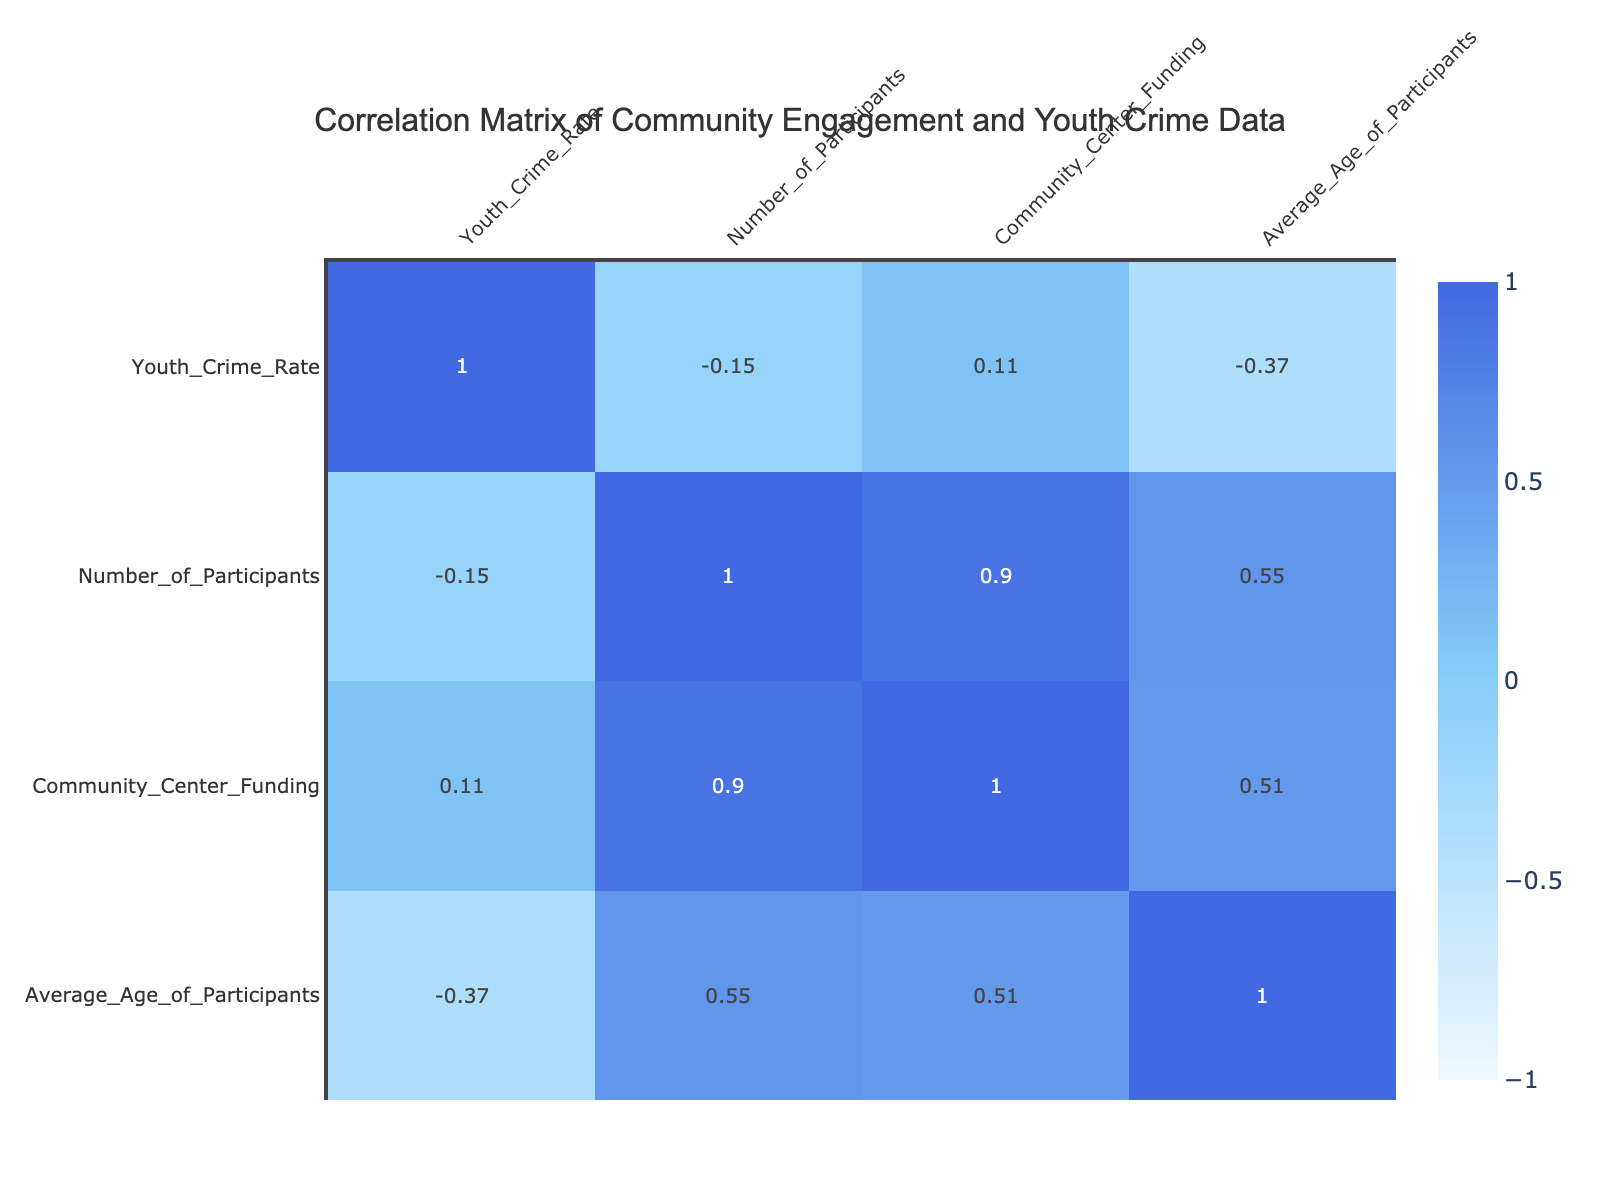What is the youth crime rate associated with Neighborhood Watch Initiatives? Referring to the table, the youth crime rate for Neighborhood Watch Initiatives is specifically listed as 20.
Answer: 20 What community engagement activity has the highest youth crime rate? When examining the table, School-based Presentations has the highest youth crime rate, recorded at 40.
Answer: School-based Presentations What is the average number of participants across all community engagement activities? To calculate the average, sum the number of participants (150 + 100 + 80 + 50 + 300 + 120 + 60 + 70 = 1030) and divide by the total number of activities (8). Thus, the average is 1030/8 = 128.75.
Answer: 128.75 Is there a community engagement activity with a youth crime rate of 15? There is no entry in the table with a youth crime rate of 15, indicating that this statement is false.
Answer: No Which activity has the lowest funding? By analyzing the funding column, Volunteer Cleanup Events has the lowest funding amount, which is 3000.
Answer: Volunteer Cleanup Events What is the relationship between the average age of participants and youth crime rate? By inspecting the table, we find there's no straightforward relationship since both variables have different values and trends, but the correlation would need to be computed for a final conclusion. Therefore, it suggests further exploration is needed.
Answer: Needs computation How many activities have a youth crime rate below 25? Checking the youth crime rates, the activities with rates below 25 are Youth Mentorship Programs (25), Neighborhood Watch Initiatives (20), Music and Dance Festivals (15), and Volunteer Cleanup Events (18), making a total of 4 activities.
Answer: 4 Which program has more participants: Music and Dance Festivals or School-based Presentations? Comparing the number of participants for Music and Dance Festivals (300) and School-based Presentations (120), Music and Dance Festivals has a significantly higher number of participants.
Answer: Music and Dance Festivals What is the total funding for all community engagement activities combined? Summing up the funding from all activities (20000 + 15000 + 10000 + 5000 + 25000 + 12000 + 3000 + 8000 = 110000) gives a total funding amount of 110000.
Answer: 110000 